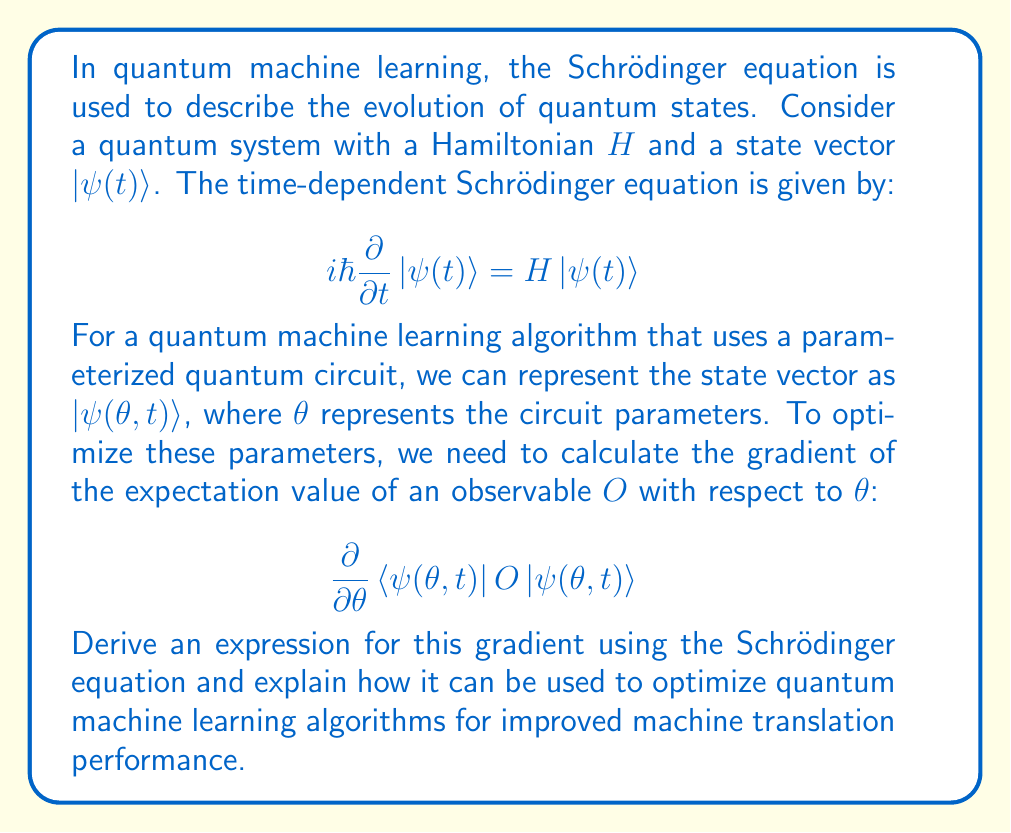Teach me how to tackle this problem. To solve this problem, we'll follow these steps:

1. Express the expectation value of the observable $O$ in terms of the state vector $|\psi(\theta, t)\rangle$.
2. Apply the product rule to differentiate the expectation value with respect to $\theta$.
3. Use the Schrödinger equation to simplify the resulting expression.
4. Interpret the result in the context of optimizing quantum machine learning algorithms for machine translation.

Step 1: Express the expectation value
The expectation value of observable $O$ is given by:

$$\langle O \rangle = \langle\psi(\theta, t)|O|\psi(\theta, t)\rangle$$

Step 2: Apply the product rule
Differentiating with respect to $\theta$:

$$\frac{\partial}{\partial \theta}\langle O \rangle = \frac{\partial}{\partial \theta}\langle\psi(\theta, t)|O|\psi(\theta, t)\rangle$$
$$= \left(\frac{\partial}{\partial \theta}\langle\psi(\theta, t)|\right)O|\psi(\theta, t)\rangle + \langle\psi(\theta, t)|O\left(\frac{\partial}{\partial \theta}|\psi(\theta, t)\rangle\right)$$

Step 3: Use the Schrödinger equation
The Schrödinger equation gives us:

$$\frac{\partial}{\partial t}|\psi(\theta, t)\rangle = -\frac{i}{\hbar}H|\psi(\theta, t)\rangle$$

We can use this to express the partial derivative with respect to $\theta$:

$$\frac{\partial}{\partial \theta}|\psi(\theta, t)\rangle = -i\int_0^t \frac{\partial H}{\partial \theta}|\psi(\theta, t')\rangle dt'$$

Substituting this into our gradient expression:

$$\frac{\partial}{\partial \theta}\langle O \rangle = -i\int_0^t \left(\langle\psi(\theta, t)|\frac{\partial H}{\partial \theta}O|\psi(\theta, t')\rangle - \langle\psi(\theta, t')|O\frac{\partial H}{\partial \theta}|\psi(\theta, t)\rangle\right) dt'$$

Step 4: Interpretation for quantum machine learning optimization
This gradient expression allows us to optimize the parameters $\theta$ of our quantum circuit to maximize or minimize the expectation value of the observable $O$. In the context of machine translation, $O$ could represent a measure of translation quality or accuracy.

To optimize the quantum machine learning algorithm:

1. Initialize the circuit parameters $\theta$.
2. Evolve the quantum state according to the Schrödinger equation.
3. Calculate the gradient using the derived expression.
4. Update the parameters using gradient descent: $\theta \rightarrow \theta - \eta \frac{\partial}{\partial \theta}\langle O \rangle$, where $\eta$ is the learning rate.
5. Repeat steps 2-4 until convergence.

This approach allows for continuous optimization of the quantum circuit, potentially leading to improved performance in machine translation tasks compared to classical algorithms.
Answer: The gradient of the expectation value of observable $O$ with respect to the circuit parameters $\theta$ is:

$$\frac{\partial}{\partial \theta}\langle O \rangle = -i\int_0^t \left(\langle\psi(\theta, t)|\frac{\partial H}{\partial \theta}O|\psi(\theta, t')\rangle - \langle\psi(\theta, t')|O\frac{\partial H}{\partial \theta}|\psi(\theta, t)\rangle\right) dt'$$

This expression can be used in a gradient descent algorithm to optimize quantum machine learning algorithms for improved machine translation performance. 